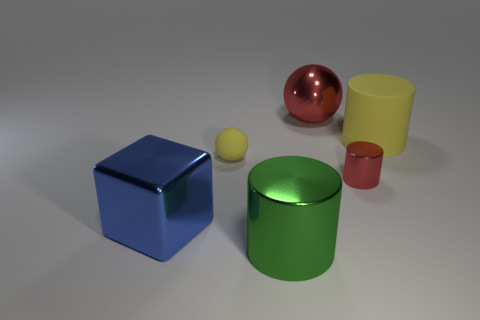Subtract all big green cylinders. How many cylinders are left? 2 Add 4 big yellow metal cylinders. How many objects exist? 10 Subtract 3 cylinders. How many cylinders are left? 0 Add 5 big red rubber things. How many big red rubber things exist? 5 Subtract all green cylinders. How many cylinders are left? 2 Subtract 0 gray balls. How many objects are left? 6 Subtract all blocks. How many objects are left? 5 Subtract all yellow cylinders. Subtract all yellow spheres. How many cylinders are left? 2 Subtract all yellow cubes. How many yellow cylinders are left? 1 Subtract all big blue metallic cubes. Subtract all rubber things. How many objects are left? 3 